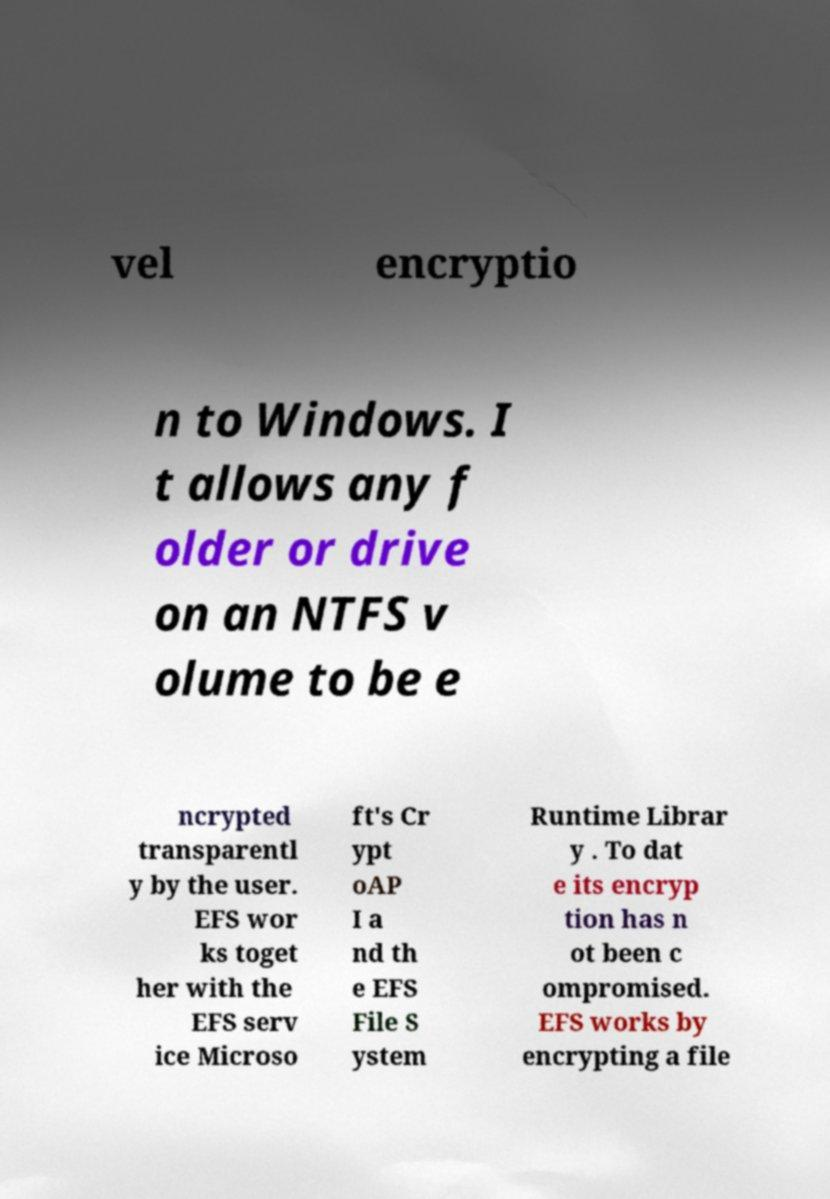What messages or text are displayed in this image? I need them in a readable, typed format. vel encryptio n to Windows. I t allows any f older or drive on an NTFS v olume to be e ncrypted transparentl y by the user. EFS wor ks toget her with the EFS serv ice Microso ft's Cr ypt oAP I a nd th e EFS File S ystem Runtime Librar y . To dat e its encryp tion has n ot been c ompromised. EFS works by encrypting a file 